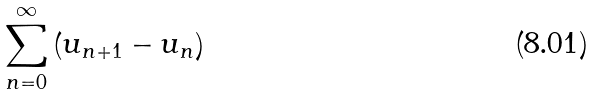Convert formula to latex. <formula><loc_0><loc_0><loc_500><loc_500>\sum _ { n = 0 } ^ { \infty } \left ( u _ { n + 1 } - u _ { n } \right )</formula> 